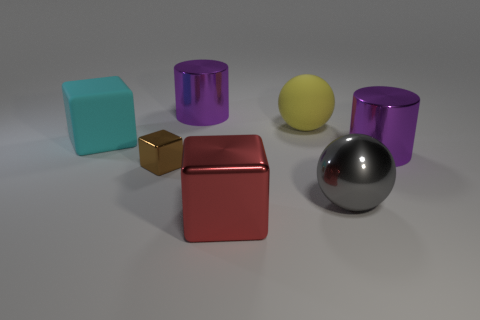Add 1 cylinders. How many objects exist? 8 Subtract all blocks. How many objects are left? 4 Subtract 0 gray blocks. How many objects are left? 7 Subtract all small purple shiny balls. Subtract all big gray shiny spheres. How many objects are left? 6 Add 5 purple cylinders. How many purple cylinders are left? 7 Add 7 large red objects. How many large red objects exist? 8 